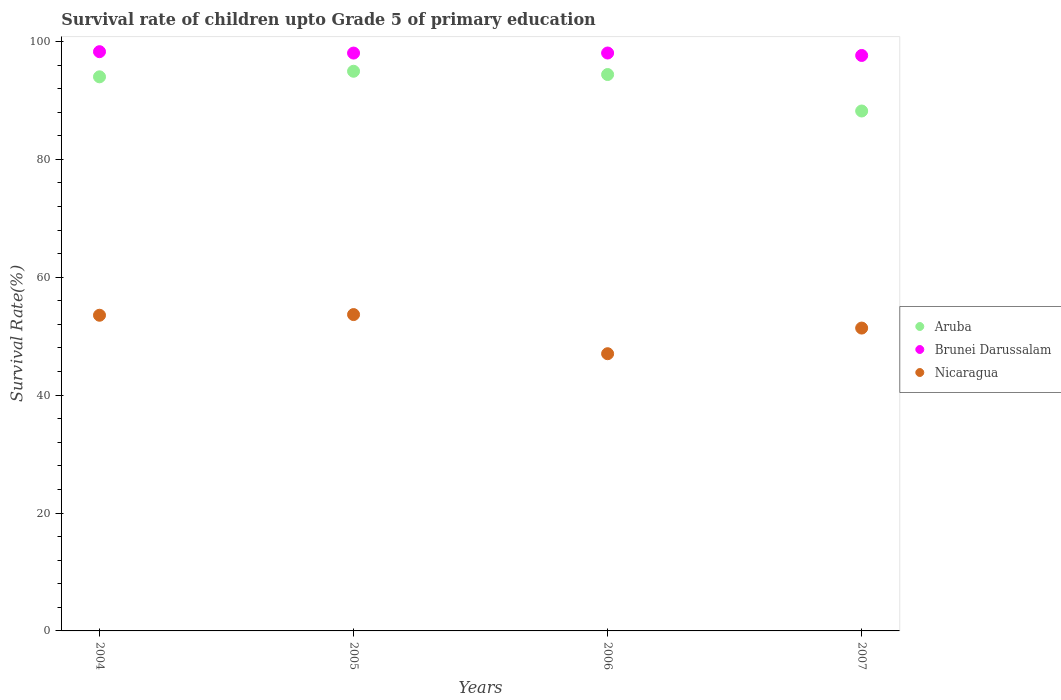Is the number of dotlines equal to the number of legend labels?
Your answer should be very brief. Yes. What is the survival rate of children in Nicaragua in 2007?
Ensure brevity in your answer.  51.38. Across all years, what is the maximum survival rate of children in Aruba?
Make the answer very short. 94.94. Across all years, what is the minimum survival rate of children in Aruba?
Offer a terse response. 88.2. What is the total survival rate of children in Brunei Darussalam in the graph?
Ensure brevity in your answer.  391.94. What is the difference between the survival rate of children in Aruba in 2004 and that in 2006?
Your answer should be very brief. -0.39. What is the difference between the survival rate of children in Brunei Darussalam in 2006 and the survival rate of children in Nicaragua in 2007?
Your answer should be compact. 46.66. What is the average survival rate of children in Aruba per year?
Your answer should be compact. 92.88. In the year 2006, what is the difference between the survival rate of children in Aruba and survival rate of children in Nicaragua?
Offer a very short reply. 47.36. In how many years, is the survival rate of children in Nicaragua greater than 56 %?
Make the answer very short. 0. What is the ratio of the survival rate of children in Nicaragua in 2006 to that in 2007?
Give a very brief answer. 0.92. Is the survival rate of children in Brunei Darussalam in 2005 less than that in 2007?
Provide a short and direct response. No. Is the difference between the survival rate of children in Aruba in 2004 and 2005 greater than the difference between the survival rate of children in Nicaragua in 2004 and 2005?
Make the answer very short. No. What is the difference between the highest and the second highest survival rate of children in Brunei Darussalam?
Offer a very short reply. 0.23. What is the difference between the highest and the lowest survival rate of children in Aruba?
Give a very brief answer. 6.74. Is it the case that in every year, the sum of the survival rate of children in Nicaragua and survival rate of children in Aruba  is greater than the survival rate of children in Brunei Darussalam?
Keep it short and to the point. Yes. How many dotlines are there?
Make the answer very short. 3. What is the difference between two consecutive major ticks on the Y-axis?
Your answer should be compact. 20. Does the graph contain any zero values?
Provide a succinct answer. No. Where does the legend appear in the graph?
Ensure brevity in your answer.  Center right. How many legend labels are there?
Ensure brevity in your answer.  3. What is the title of the graph?
Provide a short and direct response. Survival rate of children upto Grade 5 of primary education. Does "Lithuania" appear as one of the legend labels in the graph?
Ensure brevity in your answer.  No. What is the label or title of the X-axis?
Keep it short and to the point. Years. What is the label or title of the Y-axis?
Your answer should be compact. Survival Rate(%). What is the Survival Rate(%) in Aruba in 2004?
Make the answer very short. 94. What is the Survival Rate(%) of Brunei Darussalam in 2004?
Offer a very short reply. 98.26. What is the Survival Rate(%) in Nicaragua in 2004?
Offer a very short reply. 53.55. What is the Survival Rate(%) of Aruba in 2005?
Ensure brevity in your answer.  94.94. What is the Survival Rate(%) in Brunei Darussalam in 2005?
Offer a terse response. 98.03. What is the Survival Rate(%) in Nicaragua in 2005?
Give a very brief answer. 53.66. What is the Survival Rate(%) in Aruba in 2006?
Make the answer very short. 94.39. What is the Survival Rate(%) of Brunei Darussalam in 2006?
Ensure brevity in your answer.  98.03. What is the Survival Rate(%) of Nicaragua in 2006?
Make the answer very short. 47.02. What is the Survival Rate(%) in Aruba in 2007?
Provide a succinct answer. 88.2. What is the Survival Rate(%) in Brunei Darussalam in 2007?
Provide a succinct answer. 97.62. What is the Survival Rate(%) of Nicaragua in 2007?
Provide a succinct answer. 51.38. Across all years, what is the maximum Survival Rate(%) of Aruba?
Offer a very short reply. 94.94. Across all years, what is the maximum Survival Rate(%) in Brunei Darussalam?
Your answer should be compact. 98.26. Across all years, what is the maximum Survival Rate(%) in Nicaragua?
Give a very brief answer. 53.66. Across all years, what is the minimum Survival Rate(%) in Aruba?
Offer a very short reply. 88.2. Across all years, what is the minimum Survival Rate(%) of Brunei Darussalam?
Offer a terse response. 97.62. Across all years, what is the minimum Survival Rate(%) of Nicaragua?
Offer a terse response. 47.02. What is the total Survival Rate(%) in Aruba in the graph?
Keep it short and to the point. 371.52. What is the total Survival Rate(%) in Brunei Darussalam in the graph?
Make the answer very short. 391.94. What is the total Survival Rate(%) of Nicaragua in the graph?
Give a very brief answer. 205.62. What is the difference between the Survival Rate(%) in Aruba in 2004 and that in 2005?
Offer a terse response. -0.94. What is the difference between the Survival Rate(%) of Brunei Darussalam in 2004 and that in 2005?
Provide a short and direct response. 0.24. What is the difference between the Survival Rate(%) in Nicaragua in 2004 and that in 2005?
Keep it short and to the point. -0.11. What is the difference between the Survival Rate(%) in Aruba in 2004 and that in 2006?
Provide a succinct answer. -0.39. What is the difference between the Survival Rate(%) in Brunei Darussalam in 2004 and that in 2006?
Ensure brevity in your answer.  0.23. What is the difference between the Survival Rate(%) of Nicaragua in 2004 and that in 2006?
Offer a terse response. 6.53. What is the difference between the Survival Rate(%) of Aruba in 2004 and that in 2007?
Make the answer very short. 5.8. What is the difference between the Survival Rate(%) in Brunei Darussalam in 2004 and that in 2007?
Give a very brief answer. 0.64. What is the difference between the Survival Rate(%) of Nicaragua in 2004 and that in 2007?
Give a very brief answer. 2.18. What is the difference between the Survival Rate(%) in Aruba in 2005 and that in 2006?
Your response must be concise. 0.55. What is the difference between the Survival Rate(%) in Brunei Darussalam in 2005 and that in 2006?
Ensure brevity in your answer.  -0.01. What is the difference between the Survival Rate(%) in Nicaragua in 2005 and that in 2006?
Provide a short and direct response. 6.64. What is the difference between the Survival Rate(%) of Aruba in 2005 and that in 2007?
Provide a short and direct response. 6.74. What is the difference between the Survival Rate(%) in Brunei Darussalam in 2005 and that in 2007?
Provide a short and direct response. 0.41. What is the difference between the Survival Rate(%) in Nicaragua in 2005 and that in 2007?
Ensure brevity in your answer.  2.29. What is the difference between the Survival Rate(%) of Aruba in 2006 and that in 2007?
Ensure brevity in your answer.  6.19. What is the difference between the Survival Rate(%) of Brunei Darussalam in 2006 and that in 2007?
Make the answer very short. 0.42. What is the difference between the Survival Rate(%) in Nicaragua in 2006 and that in 2007?
Make the answer very short. -4.35. What is the difference between the Survival Rate(%) of Aruba in 2004 and the Survival Rate(%) of Brunei Darussalam in 2005?
Provide a succinct answer. -4.03. What is the difference between the Survival Rate(%) in Aruba in 2004 and the Survival Rate(%) in Nicaragua in 2005?
Offer a very short reply. 40.33. What is the difference between the Survival Rate(%) in Brunei Darussalam in 2004 and the Survival Rate(%) in Nicaragua in 2005?
Your answer should be very brief. 44.6. What is the difference between the Survival Rate(%) of Aruba in 2004 and the Survival Rate(%) of Brunei Darussalam in 2006?
Your answer should be very brief. -4.04. What is the difference between the Survival Rate(%) of Aruba in 2004 and the Survival Rate(%) of Nicaragua in 2006?
Your answer should be very brief. 46.97. What is the difference between the Survival Rate(%) in Brunei Darussalam in 2004 and the Survival Rate(%) in Nicaragua in 2006?
Your answer should be very brief. 51.24. What is the difference between the Survival Rate(%) of Aruba in 2004 and the Survival Rate(%) of Brunei Darussalam in 2007?
Offer a very short reply. -3.62. What is the difference between the Survival Rate(%) of Aruba in 2004 and the Survival Rate(%) of Nicaragua in 2007?
Keep it short and to the point. 42.62. What is the difference between the Survival Rate(%) of Brunei Darussalam in 2004 and the Survival Rate(%) of Nicaragua in 2007?
Give a very brief answer. 46.89. What is the difference between the Survival Rate(%) of Aruba in 2005 and the Survival Rate(%) of Brunei Darussalam in 2006?
Your answer should be very brief. -3.1. What is the difference between the Survival Rate(%) of Aruba in 2005 and the Survival Rate(%) of Nicaragua in 2006?
Provide a short and direct response. 47.92. What is the difference between the Survival Rate(%) of Brunei Darussalam in 2005 and the Survival Rate(%) of Nicaragua in 2006?
Ensure brevity in your answer.  51. What is the difference between the Survival Rate(%) in Aruba in 2005 and the Survival Rate(%) in Brunei Darussalam in 2007?
Offer a terse response. -2.68. What is the difference between the Survival Rate(%) in Aruba in 2005 and the Survival Rate(%) in Nicaragua in 2007?
Your answer should be very brief. 43.56. What is the difference between the Survival Rate(%) of Brunei Darussalam in 2005 and the Survival Rate(%) of Nicaragua in 2007?
Your answer should be compact. 46.65. What is the difference between the Survival Rate(%) of Aruba in 2006 and the Survival Rate(%) of Brunei Darussalam in 2007?
Make the answer very short. -3.23. What is the difference between the Survival Rate(%) in Aruba in 2006 and the Survival Rate(%) in Nicaragua in 2007?
Provide a succinct answer. 43.01. What is the difference between the Survival Rate(%) of Brunei Darussalam in 2006 and the Survival Rate(%) of Nicaragua in 2007?
Give a very brief answer. 46.66. What is the average Survival Rate(%) of Aruba per year?
Your answer should be very brief. 92.88. What is the average Survival Rate(%) in Brunei Darussalam per year?
Make the answer very short. 97.99. What is the average Survival Rate(%) in Nicaragua per year?
Your answer should be very brief. 51.4. In the year 2004, what is the difference between the Survival Rate(%) of Aruba and Survival Rate(%) of Brunei Darussalam?
Provide a succinct answer. -4.27. In the year 2004, what is the difference between the Survival Rate(%) of Aruba and Survival Rate(%) of Nicaragua?
Your response must be concise. 40.45. In the year 2004, what is the difference between the Survival Rate(%) in Brunei Darussalam and Survival Rate(%) in Nicaragua?
Your response must be concise. 44.71. In the year 2005, what is the difference between the Survival Rate(%) of Aruba and Survival Rate(%) of Brunei Darussalam?
Make the answer very short. -3.09. In the year 2005, what is the difference between the Survival Rate(%) in Aruba and Survival Rate(%) in Nicaragua?
Your response must be concise. 41.28. In the year 2005, what is the difference between the Survival Rate(%) in Brunei Darussalam and Survival Rate(%) in Nicaragua?
Provide a short and direct response. 44.36. In the year 2006, what is the difference between the Survival Rate(%) of Aruba and Survival Rate(%) of Brunei Darussalam?
Make the answer very short. -3.65. In the year 2006, what is the difference between the Survival Rate(%) in Aruba and Survival Rate(%) in Nicaragua?
Your response must be concise. 47.36. In the year 2006, what is the difference between the Survival Rate(%) of Brunei Darussalam and Survival Rate(%) of Nicaragua?
Offer a very short reply. 51.01. In the year 2007, what is the difference between the Survival Rate(%) in Aruba and Survival Rate(%) in Brunei Darussalam?
Provide a succinct answer. -9.42. In the year 2007, what is the difference between the Survival Rate(%) of Aruba and Survival Rate(%) of Nicaragua?
Ensure brevity in your answer.  36.82. In the year 2007, what is the difference between the Survival Rate(%) of Brunei Darussalam and Survival Rate(%) of Nicaragua?
Provide a succinct answer. 46.24. What is the ratio of the Survival Rate(%) in Nicaragua in 2004 to that in 2005?
Give a very brief answer. 1. What is the ratio of the Survival Rate(%) in Aruba in 2004 to that in 2006?
Your answer should be very brief. 1. What is the ratio of the Survival Rate(%) of Brunei Darussalam in 2004 to that in 2006?
Provide a short and direct response. 1. What is the ratio of the Survival Rate(%) in Nicaragua in 2004 to that in 2006?
Offer a terse response. 1.14. What is the ratio of the Survival Rate(%) in Aruba in 2004 to that in 2007?
Provide a succinct answer. 1.07. What is the ratio of the Survival Rate(%) of Brunei Darussalam in 2004 to that in 2007?
Offer a very short reply. 1.01. What is the ratio of the Survival Rate(%) of Nicaragua in 2004 to that in 2007?
Offer a terse response. 1.04. What is the ratio of the Survival Rate(%) of Aruba in 2005 to that in 2006?
Your response must be concise. 1.01. What is the ratio of the Survival Rate(%) in Brunei Darussalam in 2005 to that in 2006?
Provide a succinct answer. 1. What is the ratio of the Survival Rate(%) of Nicaragua in 2005 to that in 2006?
Offer a terse response. 1.14. What is the ratio of the Survival Rate(%) in Aruba in 2005 to that in 2007?
Provide a succinct answer. 1.08. What is the ratio of the Survival Rate(%) of Nicaragua in 2005 to that in 2007?
Your answer should be very brief. 1.04. What is the ratio of the Survival Rate(%) in Aruba in 2006 to that in 2007?
Make the answer very short. 1.07. What is the ratio of the Survival Rate(%) of Brunei Darussalam in 2006 to that in 2007?
Give a very brief answer. 1. What is the ratio of the Survival Rate(%) in Nicaragua in 2006 to that in 2007?
Offer a terse response. 0.92. What is the difference between the highest and the second highest Survival Rate(%) in Aruba?
Your response must be concise. 0.55. What is the difference between the highest and the second highest Survival Rate(%) in Brunei Darussalam?
Ensure brevity in your answer.  0.23. What is the difference between the highest and the second highest Survival Rate(%) of Nicaragua?
Ensure brevity in your answer.  0.11. What is the difference between the highest and the lowest Survival Rate(%) of Aruba?
Provide a succinct answer. 6.74. What is the difference between the highest and the lowest Survival Rate(%) in Brunei Darussalam?
Your answer should be compact. 0.64. What is the difference between the highest and the lowest Survival Rate(%) in Nicaragua?
Offer a very short reply. 6.64. 